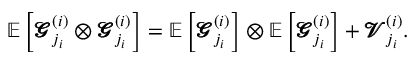<formula> <loc_0><loc_0><loc_500><loc_500>\mathbb { E } \left [ \pm b { \ m a t h s c r { G } } _ { j _ { i } } ^ { ( i ) } \otimes \pm b { \ m a t h s c r { G } } _ { j _ { i } } ^ { ( i ) } \right ] = \mathbb { E } \left [ \pm b { \ m a t h s c r { G } } _ { j _ { i } } ^ { ( i ) } \right ] \otimes \mathbb { E } \left [ \pm b { \ m a t h s c r { G } } _ { j _ { i } } ^ { ( i ) } \right ] + \pm b { \ m a t h s c r { V } } _ { j _ { i } } ^ { ( i ) } .</formula> 